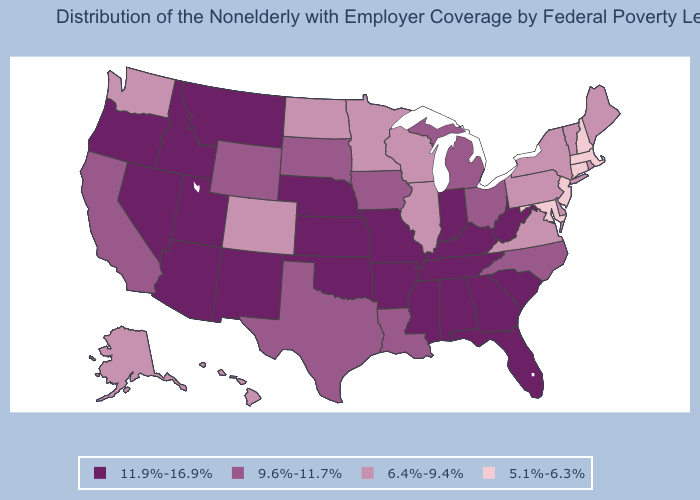Does New Jersey have the lowest value in the USA?
Short answer required. Yes. What is the value of Kentucky?
Answer briefly. 11.9%-16.9%. Does North Carolina have the same value as South Dakota?
Keep it brief. Yes. What is the value of Washington?
Write a very short answer. 6.4%-9.4%. Does Mississippi have a lower value than New Hampshire?
Answer briefly. No. Does Michigan have the same value as Minnesota?
Answer briefly. No. What is the value of Michigan?
Short answer required. 9.6%-11.7%. Does the first symbol in the legend represent the smallest category?
Be succinct. No. Name the states that have a value in the range 6.4%-9.4%?
Be succinct. Alaska, Colorado, Delaware, Hawaii, Illinois, Maine, Minnesota, New York, North Dakota, Pennsylvania, Rhode Island, Vermont, Virginia, Washington, Wisconsin. Is the legend a continuous bar?
Keep it brief. No. Name the states that have a value in the range 6.4%-9.4%?
Concise answer only. Alaska, Colorado, Delaware, Hawaii, Illinois, Maine, Minnesota, New York, North Dakota, Pennsylvania, Rhode Island, Vermont, Virginia, Washington, Wisconsin. What is the value of North Carolina?
Concise answer only. 9.6%-11.7%. What is the lowest value in the MidWest?
Keep it brief. 6.4%-9.4%. What is the highest value in the Northeast ?
Quick response, please. 6.4%-9.4%. 